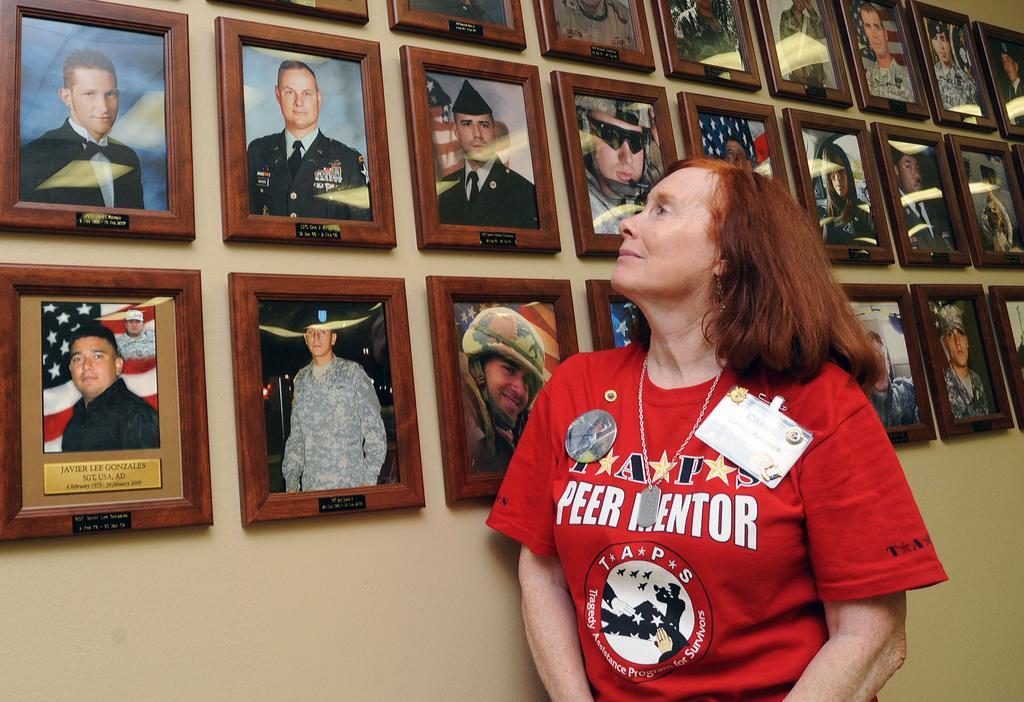In one or two sentences, can you explain what this image depicts? In this image we can see a person standing near the wall. And we can see the photo frames attached to the wall. 